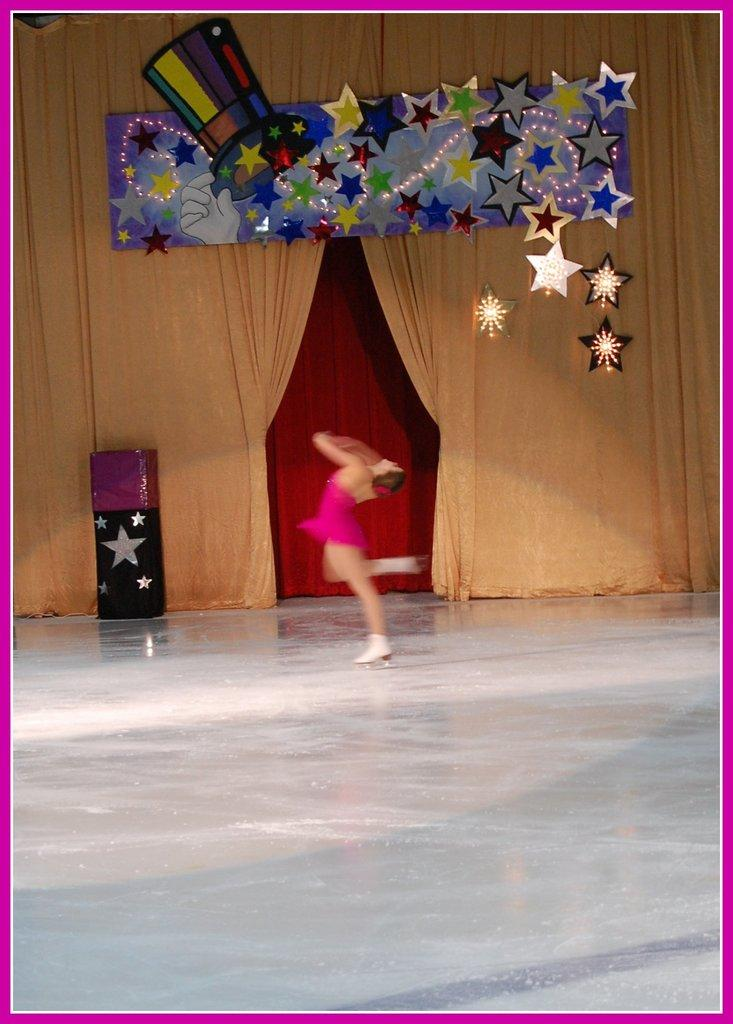What is happening in the image? There is a picture dancing on the floor in the image. What can be seen in the background of the image? There is a cream-colored curtain in the background of the image. Where is the cactus located in the image? There is no cactus present in the image. What type of nail is being used by the dancing picture in the image? The dancing picture is not using any nail, as it is a two-dimensional image. 